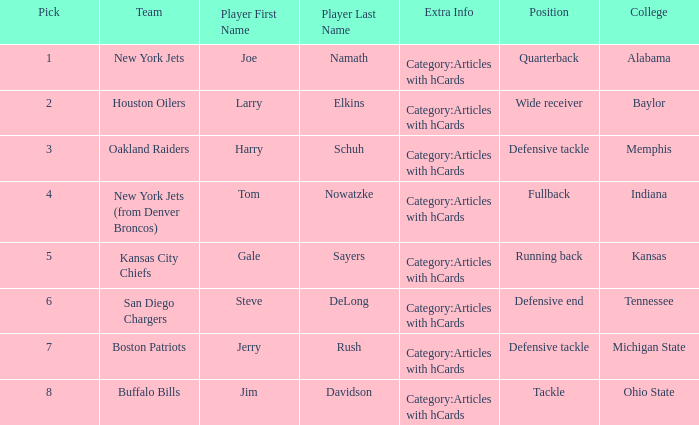What is the highest pick for the position of defensive end? 6.0. 